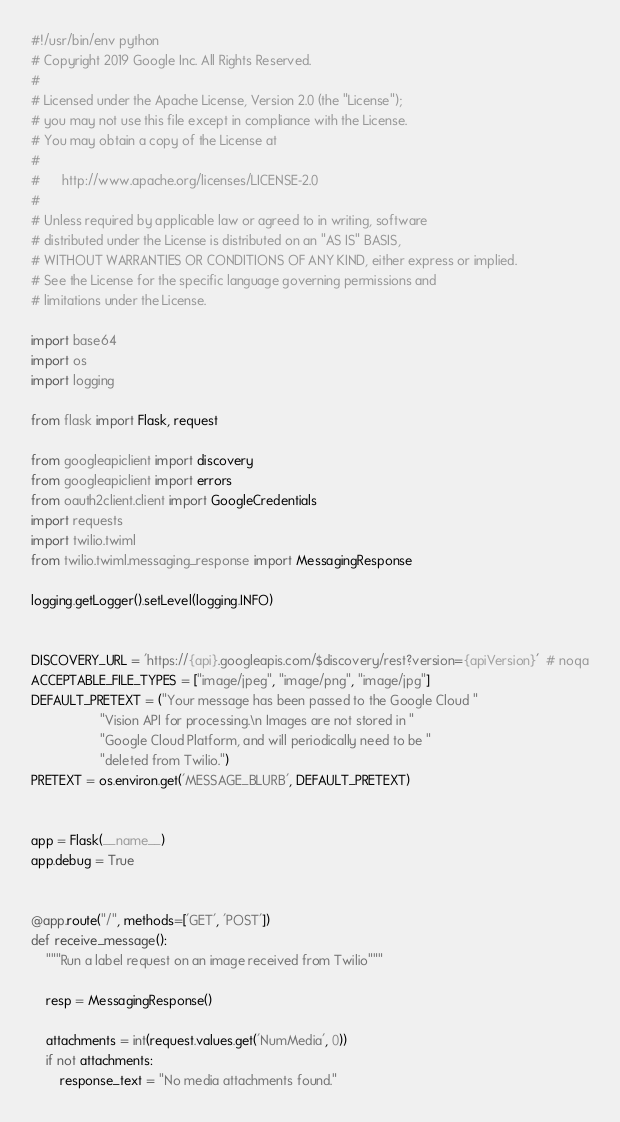<code> <loc_0><loc_0><loc_500><loc_500><_Python_>#!/usr/bin/env python
# Copyright 2019 Google Inc. All Rights Reserved.
#
# Licensed under the Apache License, Version 2.0 (the "License");
# you may not use this file except in compliance with the License.
# You may obtain a copy of the License at
#
#      http://www.apache.org/licenses/LICENSE-2.0
#
# Unless required by applicable law or agreed to in writing, software
# distributed under the License is distributed on an "AS IS" BASIS,
# WITHOUT WARRANTIES OR CONDITIONS OF ANY KIND, either express or implied.
# See the License for the specific language governing permissions and
# limitations under the License.

import base64
import os
import logging

from flask import Flask, request

from googleapiclient import discovery
from googleapiclient import errors
from oauth2client.client import GoogleCredentials
import requests
import twilio.twiml
from twilio.twiml.messaging_response import MessagingResponse

logging.getLogger().setLevel(logging.INFO)


DISCOVERY_URL = 'https://{api}.googleapis.com/$discovery/rest?version={apiVersion}'  # noqa
ACCEPTABLE_FILE_TYPES = ["image/jpeg", "image/png", "image/jpg"]
DEFAULT_PRETEXT = ("Your message has been passed to the Google Cloud "
                   "Vision API for processing.\n Images are not stored in "
                   "Google Cloud Platform, and will periodically need to be "
                   "deleted from Twilio.")
PRETEXT = os.environ.get('MESSAGE_BLURB', DEFAULT_PRETEXT)


app = Flask(__name__)
app.debug = True


@app.route("/", methods=['GET', 'POST'])
def receive_message():
    """Run a label request on an image received from Twilio"""

    resp = MessagingResponse()

    attachments = int(request.values.get('NumMedia', 0))
    if not attachments:
        response_text = "No media attachments found."</code> 